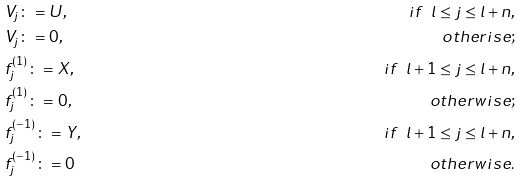<formula> <loc_0><loc_0><loc_500><loc_500>& V _ { j } \colon = U , \ \ & i f \ \ l \leq j \leq l + n , \\ & V _ { j } \colon = 0 , \ & o t h e r i s e ; \\ & f _ { j } ^ { ( 1 ) } \colon = X , & i f \ \ l + 1 \leq j \leq l + n , \\ & f _ { j } ^ { ( 1 ) } \colon = 0 , & o t h e r w i s e ; \\ & f _ { j } ^ { ( - 1 ) } \colon = Y , \ & i f \ \ l + 1 \leq j \leq l + n , \\ & f _ { j } ^ { ( - 1 ) } \colon = 0 & o t h e r w i s e .</formula> 